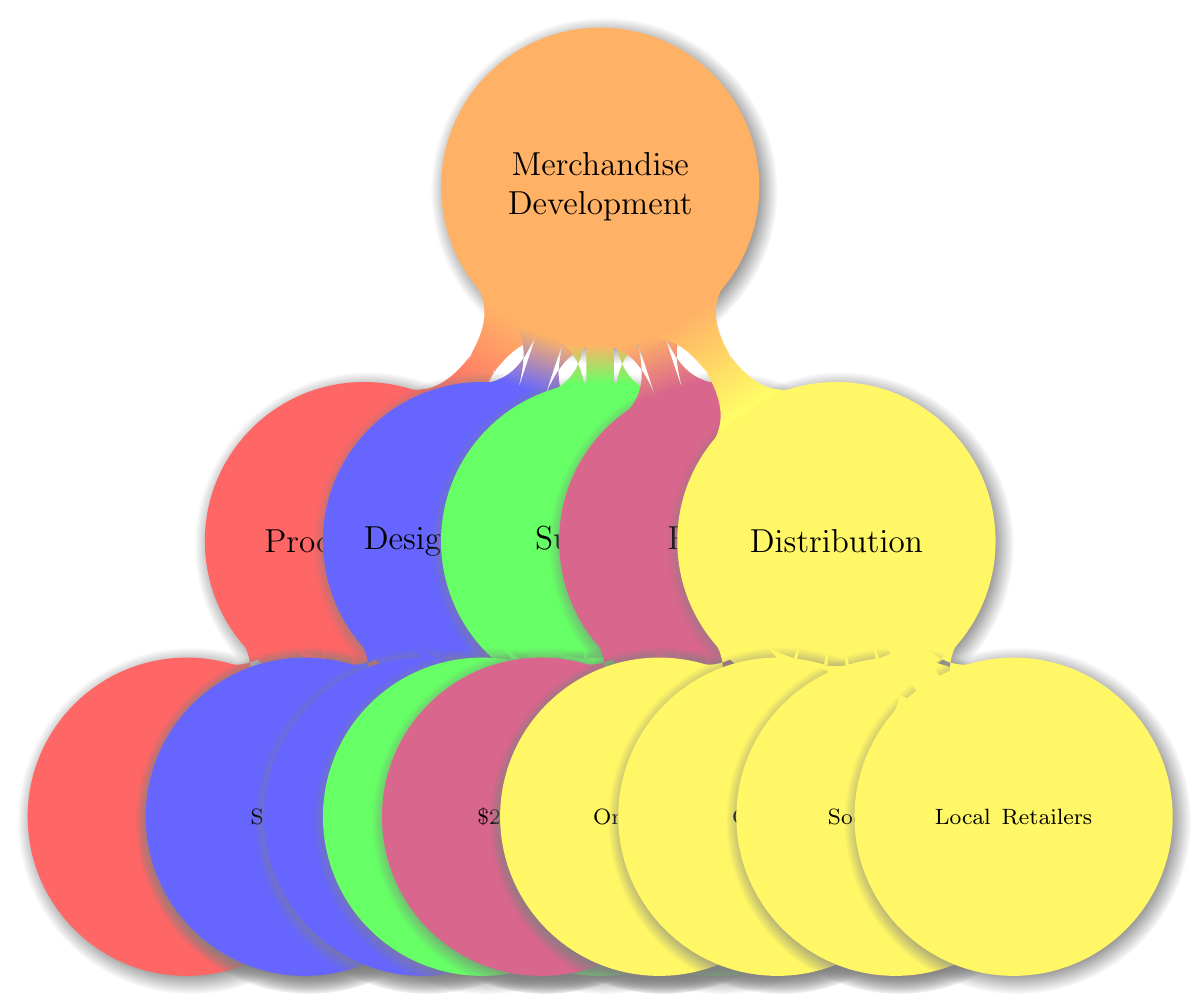What are the product ideas listed in the diagram? The diagram indicates four product ideas under "Product Ideas": T-shirts, Hoodies, Accessories, and Posters.
Answer: T-shirts, Hoodies, Accessories, Posters How many design concepts are presented? The diagram shows four distinct design concepts under "Design Concepts": Streetwear Aesthetic, Color Schemes, Artwork, and Slogan Incorporation. This totals to four concepts.
Answer: 4 Which supplier is listed for T-shirts? The diagram specifies "Printful" as the supplier for custom-printed T-shirts and hoodies.
Answer: Printful What is the pricing of hoodies according to the diagram? The diagram clearly states that hoodies are priced at $50 each.
Answer: $50 hoodies Which distribution channel is associated with global reach? The diagram associates the "Online Store" with global reach, indicating that it utilizes a Shopify store for this purpose.
Answer: Online Store What color schemes are suggested in the design concepts? The design concepts include a suggestion for "Bold colors like black, red, and gold." This indicates the focus on vibrant color schemes.
Answer: Bold colors like black, red, and gold If the price range of accessories is between $10 to $20, what is the average price? The average price can be calculated as the midpoint of the price range, which is (10+20)/2 = 15. Therefore, the average price of accessories is $15.
Answer: $15 Which product has the highest listed price? By comparing the prices listed: T-shirts are $25, Hoodies are $50, Accessories range from $10 to $20, and Posters are $15. Therefore, hoodies have the highest price.
Answer: Hoodies How many accessory types are mentioned? The diagram specifies multiple accessories: snapback hats, phone cases, and enamel pins. This indicates there are three types of accessories mentioned in the diagram.
Answer: 3 